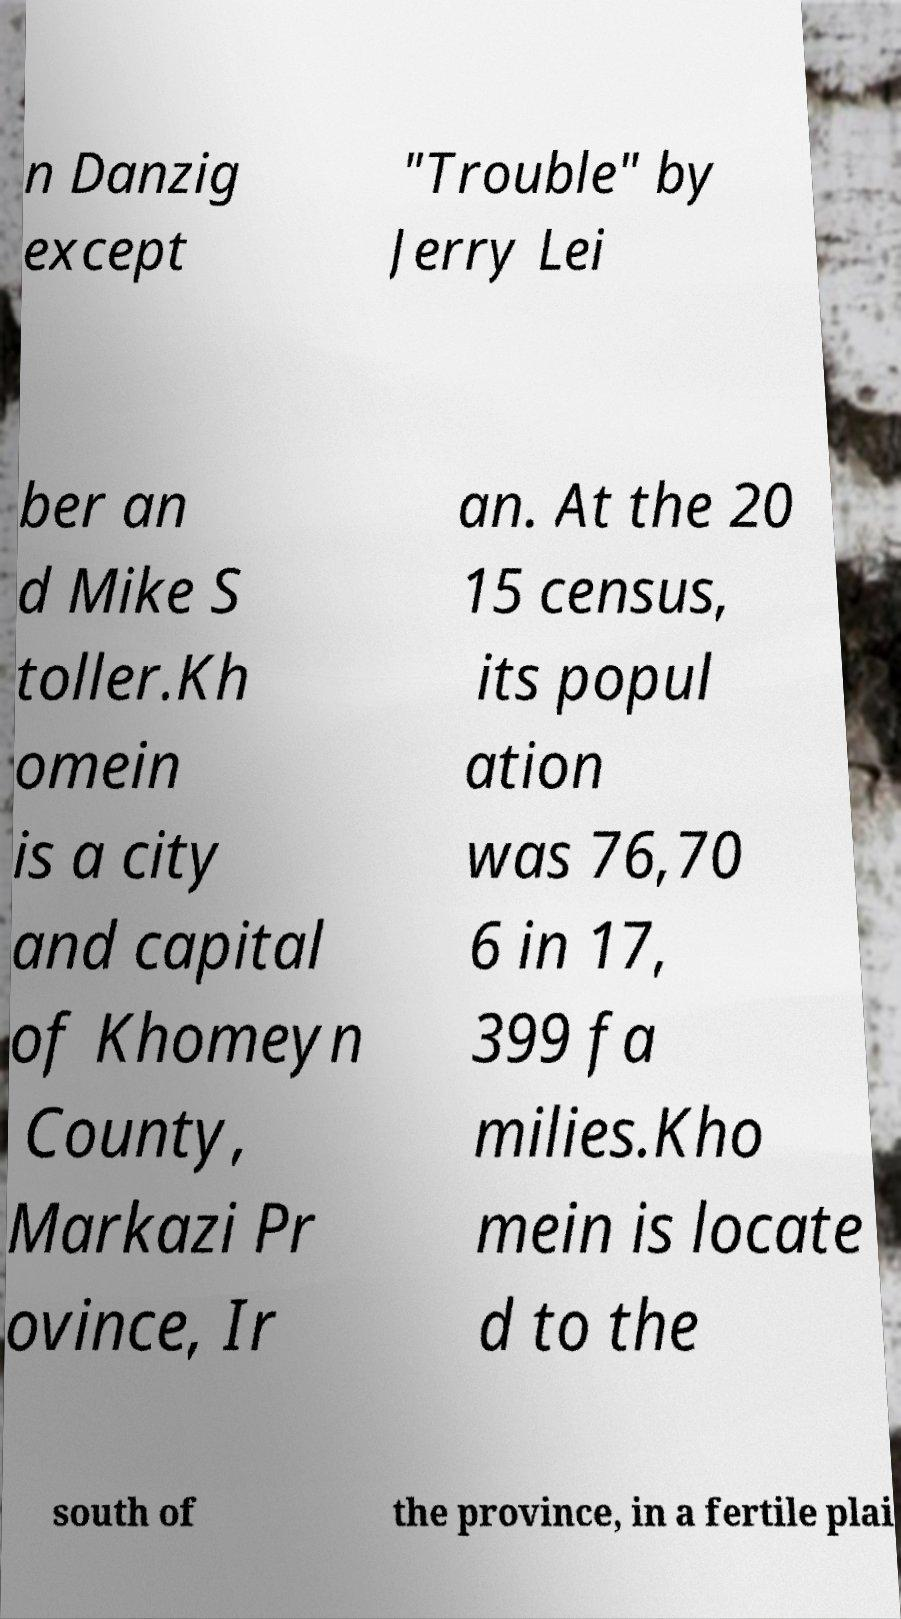What messages or text are displayed in this image? I need them in a readable, typed format. n Danzig except "Trouble" by Jerry Lei ber an d Mike S toller.Kh omein is a city and capital of Khomeyn County, Markazi Pr ovince, Ir an. At the 20 15 census, its popul ation was 76,70 6 in 17, 399 fa milies.Kho mein is locate d to the south of the province, in a fertile plai 